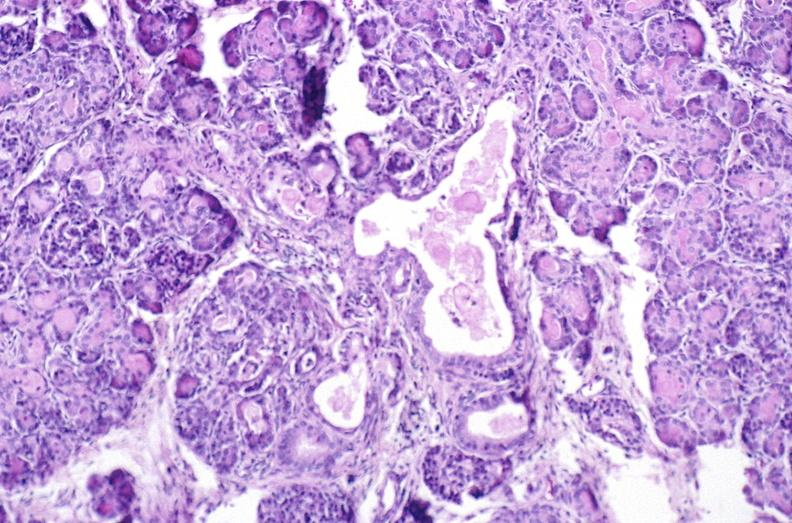what is present?
Answer the question using a single word or phrase. Pancreas 